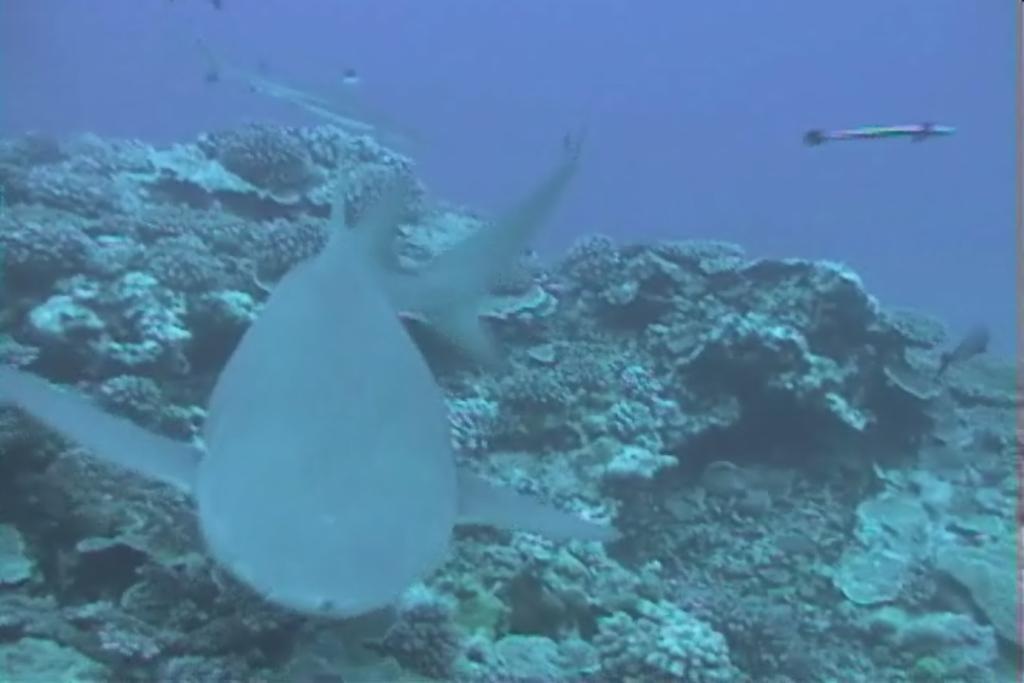What type of animal can be seen in the image? There is an aquatic animal in the image. What else is visible in the image besides the animal? There are rocks visible in the image. Where are the rocks located in relation to the water? The rocks are in the water. What color is the water in the image? The water is in blue color. How many tomatoes can be seen growing on the rocks in the image? There are no tomatoes present in the image; it features an aquatic animal, rocks, and water. What type of creator is responsible for the design of the rocks in the image? The image does not provide information about the creator of the rocks, as it is a natural scene. 